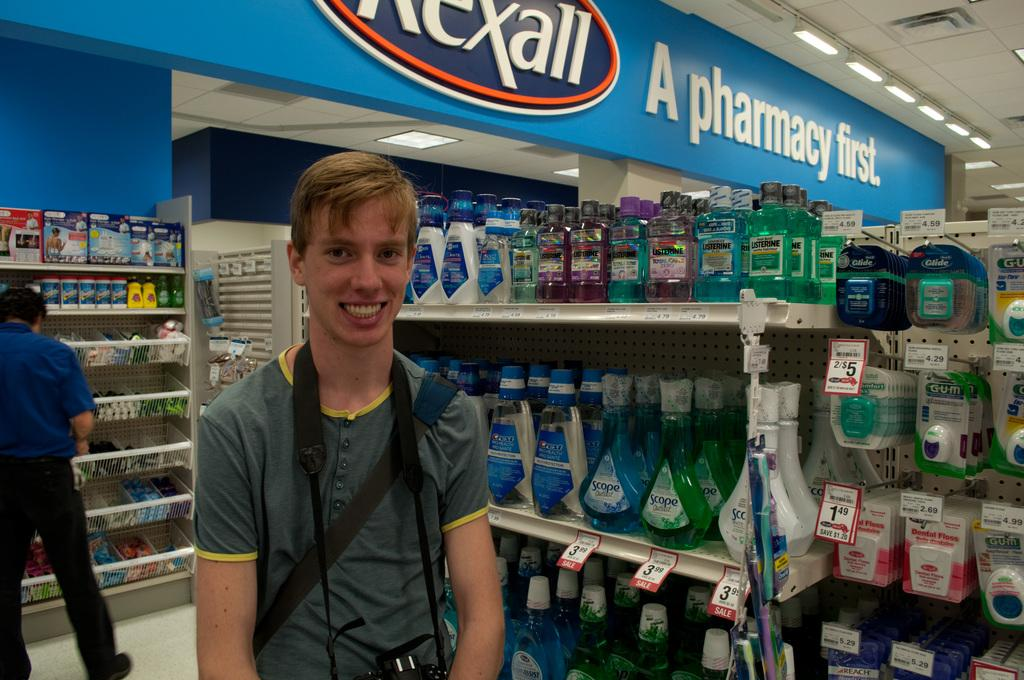<image>
Offer a succinct explanation of the picture presented. A guy in a pharmacy below a sign which reads "rexall A pharmacy first." 